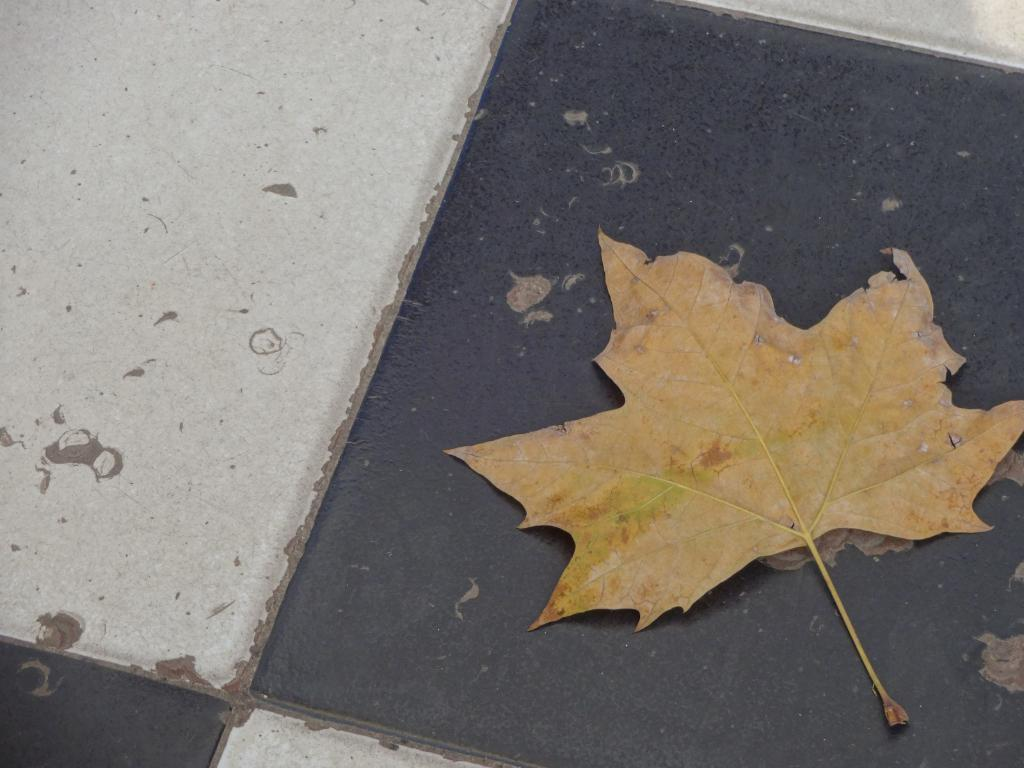What is on the floor in the image? There is a leaf on the floor in the image. What type of plastic detail can be seen on the leaf in the image? There is no plastic detail present on the leaf in the image, as it is a natural object. How many tomatoes are visible on the leaf in the image? There are no tomatoes present in the image, as it only features a leaf on the floor. 